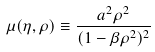<formula> <loc_0><loc_0><loc_500><loc_500>\mu ( \eta , \rho ) \equiv \frac { a ^ { 2 } \rho ^ { 2 } } { ( 1 - \beta \rho ^ { 2 } ) ^ { 2 } }</formula> 